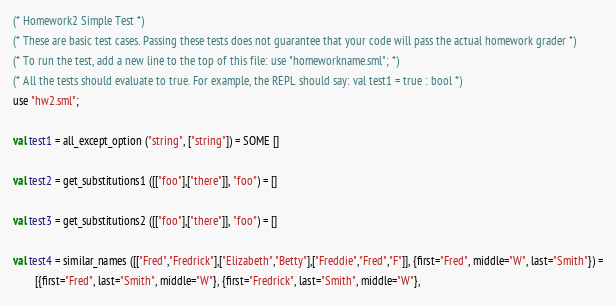Convert code to text. <code><loc_0><loc_0><loc_500><loc_500><_SML_>(* Homework2 Simple Test *)
(* These are basic test cases. Passing these tests does not guarantee that your code will pass the actual homework grader *)
(* To run the test, add a new line to the top of this file: use "homeworkname.sml"; *)
(* All the tests should evaluate to true. For example, the REPL should say: val test1 = true : bool *)
use "hw2.sml";

val test1 = all_except_option ("string", ["string"]) = SOME []

val test2 = get_substitutions1 ([["foo"],["there"]], "foo") = []

val test3 = get_substitutions2 ([["foo"],["there"]], "foo") = []

val test4 = similar_names ([["Fred","Fredrick"],["Elizabeth","Betty"],["Freddie","Fred","F"]], {first="Fred", middle="W", last="Smith"}) =
	    [{first="Fred", last="Smith", middle="W"}, {first="Fredrick", last="Smith", middle="W"},</code> 